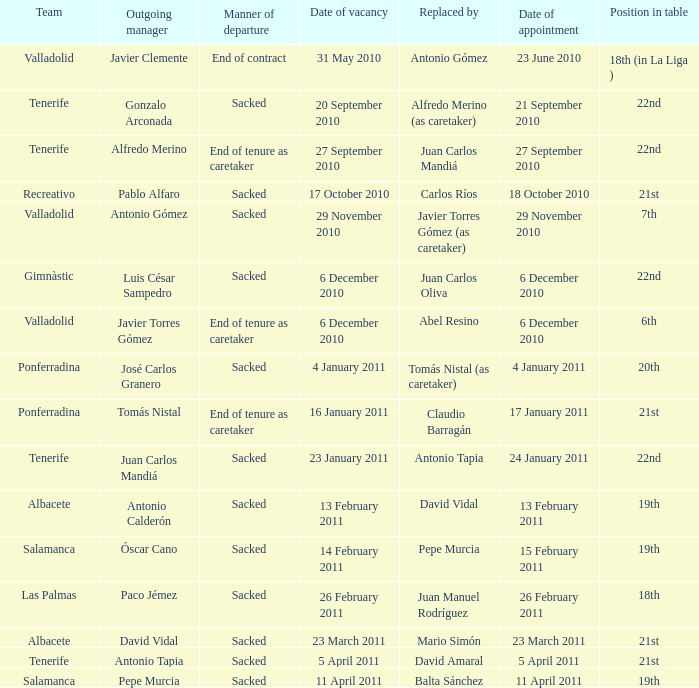How many teams had a booked date of 11 april 2011? 1.0. 